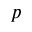<formula> <loc_0><loc_0><loc_500><loc_500>p</formula> 